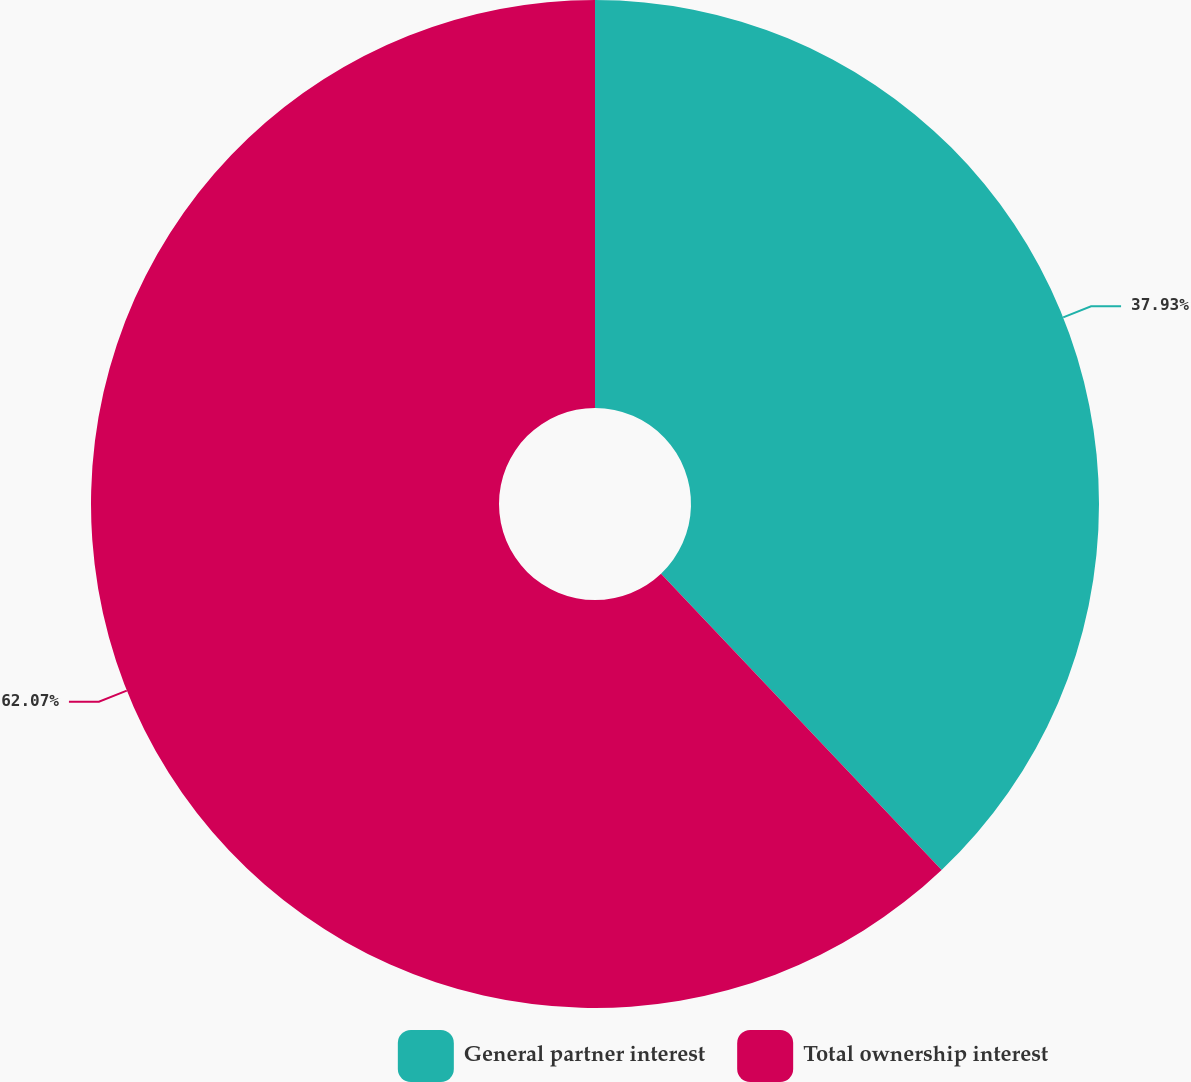Convert chart to OTSL. <chart><loc_0><loc_0><loc_500><loc_500><pie_chart><fcel>General partner interest<fcel>Total ownership interest<nl><fcel>37.93%<fcel>62.07%<nl></chart> 